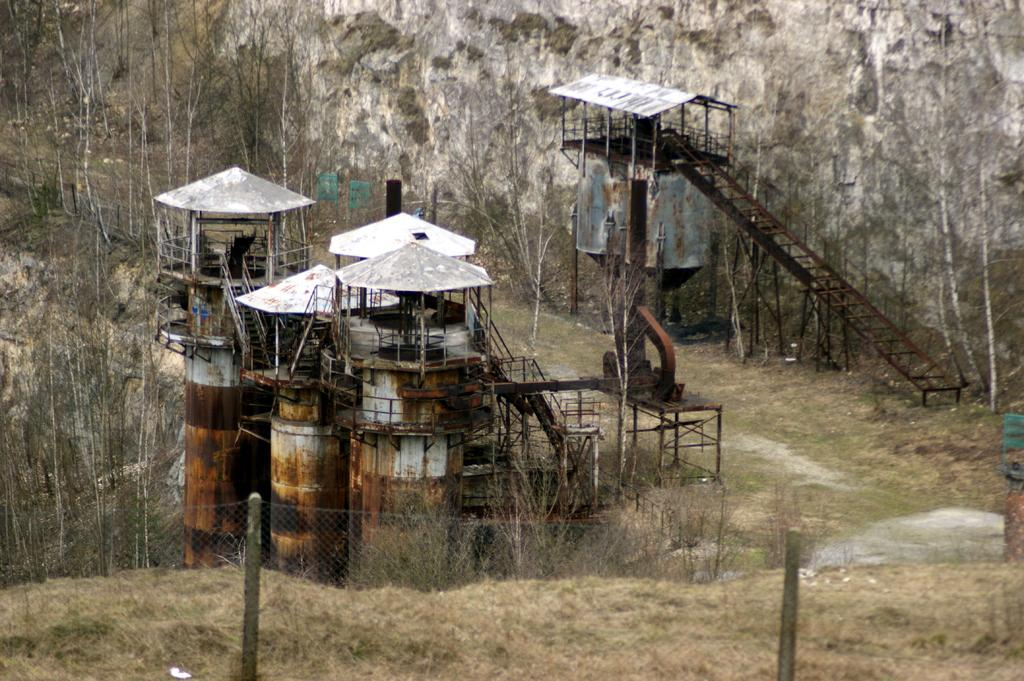What type of natural elements can be seen in the image? There are many trees in the image. What type of structure is present in the image? There is a fencing in the image. What type of geographical feature is visible in the image? There is a hill in the image. What type of object can be seen on the ground in the image? There is a rock in the image. What type of man-made object is present in the image? There is machinery in the image. What type of liquid is dripping from the trees in the image? There is no liquid dripping from the trees in the image. What type of substance is being used to write on the rocks in the image? There is no writing or substance present on the rocks in the image. 